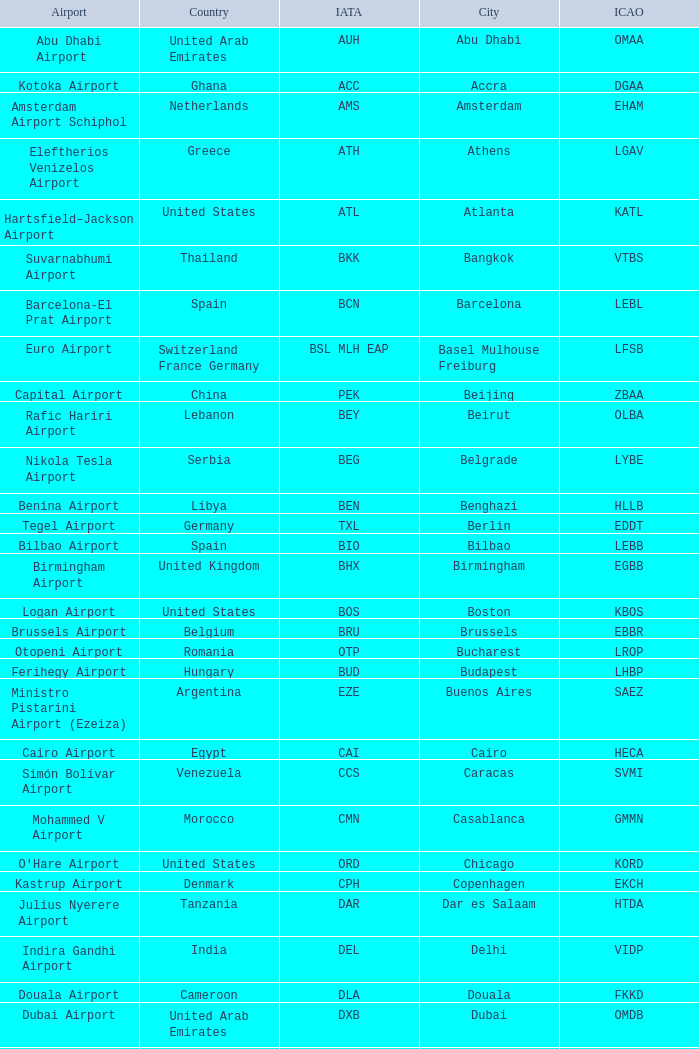Could you parse the entire table as a dict? {'header': ['Airport', 'Country', 'IATA', 'City', 'ICAO'], 'rows': [['Abu Dhabi Airport', 'United Arab Emirates', 'AUH', 'Abu Dhabi', 'OMAA'], ['Kotoka Airport', 'Ghana', 'ACC', 'Accra', 'DGAA'], ['Amsterdam Airport Schiphol', 'Netherlands', 'AMS', 'Amsterdam', 'EHAM'], ['Eleftherios Venizelos Airport', 'Greece', 'ATH', 'Athens', 'LGAV'], ['Hartsfield–Jackson Airport', 'United States', 'ATL', 'Atlanta', 'KATL'], ['Suvarnabhumi Airport', 'Thailand', 'BKK', 'Bangkok', 'VTBS'], ['Barcelona-El Prat Airport', 'Spain', 'BCN', 'Barcelona', 'LEBL'], ['Euro Airport', 'Switzerland France Germany', 'BSL MLH EAP', 'Basel Mulhouse Freiburg', 'LFSB'], ['Capital Airport', 'China', 'PEK', 'Beijing', 'ZBAA'], ['Rafic Hariri Airport', 'Lebanon', 'BEY', 'Beirut', 'OLBA'], ['Nikola Tesla Airport', 'Serbia', 'BEG', 'Belgrade', 'LYBE'], ['Benina Airport', 'Libya', 'BEN', 'Benghazi', 'HLLB'], ['Tegel Airport', 'Germany', 'TXL', 'Berlin', 'EDDT'], ['Bilbao Airport', 'Spain', 'BIO', 'Bilbao', 'LEBB'], ['Birmingham Airport', 'United Kingdom', 'BHX', 'Birmingham', 'EGBB'], ['Logan Airport', 'United States', 'BOS', 'Boston', 'KBOS'], ['Brussels Airport', 'Belgium', 'BRU', 'Brussels', 'EBBR'], ['Otopeni Airport', 'Romania', 'OTP', 'Bucharest', 'LROP'], ['Ferihegy Airport', 'Hungary', 'BUD', 'Budapest', 'LHBP'], ['Ministro Pistarini Airport (Ezeiza)', 'Argentina', 'EZE', 'Buenos Aires', 'SAEZ'], ['Cairo Airport', 'Egypt', 'CAI', 'Cairo', 'HECA'], ['Simón Bolívar Airport', 'Venezuela', 'CCS', 'Caracas', 'SVMI'], ['Mohammed V Airport', 'Morocco', 'CMN', 'Casablanca', 'GMMN'], ["O'Hare Airport", 'United States', 'ORD', 'Chicago', 'KORD'], ['Kastrup Airport', 'Denmark', 'CPH', 'Copenhagen', 'EKCH'], ['Julius Nyerere Airport', 'Tanzania', 'DAR', 'Dar es Salaam', 'HTDA'], ['Indira Gandhi Airport', 'India', 'DEL', 'Delhi', 'VIDP'], ['Douala Airport', 'Cameroon', 'DLA', 'Douala', 'FKKD'], ['Dubai Airport', 'United Arab Emirates', 'DXB', 'Dubai', 'OMDB'], ['Dublin Airport', 'Ireland', 'DUB', 'Dublin', 'EIDW'], ['Lohausen Airport', 'Germany', 'DUS', 'Düsseldorf', 'EDDL'], ['Peretola Airport', 'Italy', 'FLR', 'Florence', 'LIRQ'], ['Frankfurt am Main Airport', 'Germany', 'FRA', 'Frankfurt', 'EDDF'], ['Cointrin Airport', 'Switzerland', 'GVA', 'Geneva', 'LSGG'], ['Cristoforo Colombo Airport', 'Italy', 'GOA', 'Genoa', 'LIMJ'], ['Gothenburg-Landvetter Airport', 'Sweden', 'GOT', 'Gothenburg [begins 2013-12-14]', 'ESGG'], ['Fuhlsbüttel Airport', 'Germany', 'HAM', 'Hamburg', 'EDDH'], ['Langenhagen Airport', 'Germany', 'HAJ', 'Hannover', 'EDDV'], ['Vantaa Airport', 'Finland', 'HEL', 'Helsinki', 'EFHK'], ['Tan Son Nhat Airport', 'Vietnam', 'SGN', 'Ho Chi Minh City', 'VVTS'], ['Chek Lap Kok Airport', 'Hong Kong', 'HKG', 'Hong Kong', 'VHHH'], ['Atatürk Airport', 'Turkey', 'IST', 'Istanbul', 'LTBA'], ['Soekarno–Hatta Airport', 'Indonesia', 'CGK', 'Jakarta', 'WIII'], ['King Abdulaziz Airport', 'Saudi Arabia', 'JED', 'Jeddah', 'OEJN'], ['OR Tambo Airport', 'South Africa', 'JNB', 'Johannesburg', 'FAJS'], ['Jinnah Airport', 'Pakistan', 'KHI', 'Karachi', 'OPKC'], ['Boryspil International Airport', 'Ukraine', 'KBP', 'Kiev', 'UKBB'], ['Murtala Muhammed Airport', 'Nigeria', 'LOS', 'Lagos', 'DNMM'], ["Leon M'ba Airport", 'Gabon', 'LBV', 'Libreville', 'FOOL'], ['Portela Airport', 'Portugal', 'LIS', 'Lisbon', 'LPPT'], ['City Airport', 'United Kingdom', 'LCY', 'London', 'EGLC'], ['Gatwick Airport', 'United Kingdom', 'LGW', 'London [begins 2013-12-14]', 'EGKK'], ['Heathrow Airport', 'United Kingdom', 'LHR', 'London', 'EGLL'], ['Los Angeles International Airport', 'United States', 'LAX', 'Los Angeles', 'KLAX'], ['Agno Airport', 'Switzerland', 'LUG', 'Lugano', 'LSZA'], ['Findel Airport', 'Luxembourg', 'LUX', 'Luxembourg City', 'ELLX'], ['Saint-Exupéry Airport', 'France', 'LYS', 'Lyon', 'LFLL'], ['Madrid-Barajas Airport', 'Spain', 'MAD', 'Madrid', 'LEMD'], ['Saint Isabel Airport', 'Equatorial Guinea', 'SSG', 'Malabo', 'FGSL'], ['Málaga-Costa del Sol Airport', 'Spain', 'AGP', 'Malaga', 'LEMG'], ['Ringway Airport', 'United Kingdom', 'MAN', 'Manchester', 'EGCC'], ['Ninoy Aquino Airport', 'Philippines', 'MNL', 'Manila', 'RPLL'], ['Menara Airport', 'Morocco', 'RAK', 'Marrakech [begins 2013-11-01]', 'GMMX'], ['Miami Airport', 'United States', 'MIA', 'Miami', 'KMIA'], ['Malpensa Airport', 'Italy', 'MXP', 'Milan', 'LIMC'], ['Minneapolis Airport', 'United States', 'MSP', 'Minneapolis', 'KMSP'], ['Pierre Elliott Trudeau Airport', 'Canada', 'YUL', 'Montreal', 'CYUL'], ['Domodedovo Airport', 'Russia', 'DME', 'Moscow', 'UUDD'], ['Chhatrapati Shivaji Airport', 'India', 'BOM', 'Mumbai', 'VABB'], ['Franz Josef Strauss Airport', 'Germany', 'MUC', 'Munich', 'EDDM'], ['Seeb Airport', 'Oman', 'MCT', 'Muscat', 'OOMS'], ['Jomo Kenyatta Airport', 'Kenya', 'NBO', 'Nairobi', 'HKJK'], ['Liberty Airport', 'United States', 'EWR', 'Newark', 'KEWR'], ['John F Kennedy Airport', 'United States', 'JFK', 'New York City', 'KJFK'], ["Côte d'Azur Airport", 'France', 'NCE', 'Nice', 'LFMN'], ['Nuremberg Airport', 'Germany', 'NUE', 'Nuremberg', 'EDDN'], ['Gardermoen Airport', 'Norway', 'OSL', 'Oslo', 'ENGM'], ['Palma de Mallorca Airport', 'Spain', 'PMI', 'Palma de Mallorca', 'LFPA'], ['Charles de Gaulle Airport', 'France', 'CDG', 'Paris', 'LFPG'], ['Francisco de Sa Carneiro Airport', 'Portugal', 'OPO', 'Porto', 'LPPR'], ['Ruzyně Airport', 'Czech Republic', 'PRG', 'Prague', 'LKPR'], ['Riga Airport', 'Latvia', 'RIX', 'Riga', 'EVRA'], ['Galeão Airport', 'Brazil', 'GIG', 'Rio de Janeiro [resumes 2014-7-14]', 'SBGL'], ['King Khalid Airport', 'Saudi Arabia', 'RUH', 'Riyadh', 'OERK'], ['Leonardo da Vinci Airport', 'Italy', 'FCO', 'Rome', 'LIRF'], ['Pulkovo Airport', 'Russia', 'LED', 'Saint Petersburg', 'ULLI'], ['San Francisco Airport', 'United States', 'SFO', 'San Francisco', 'KSFO'], ['Comodoro Arturo Benitez Airport', 'Chile', 'SCL', 'Santiago', 'SCEL'], ['Guarulhos Airport', 'Brazil', 'GRU', 'São Paulo', 'SBGR'], ['Butmir Airport', 'Bosnia and Herzegovina', 'SJJ', 'Sarajevo', 'LQSA'], ['Sea-Tac Airport', 'United States', 'SEA', 'Seattle', 'KSEA'], ['Pudong Airport', 'China', 'PVG', 'Shanghai', 'ZSPD'], ['Changi Airport', 'Singapore', 'SIN', 'Singapore', 'WSSS'], ['Alexander the Great Airport', 'Republic of Macedonia', 'SKP', 'Skopje', 'LWSK'], ['Vrazhdebna Airport', 'Bulgaria', 'SOF', 'Sofia', 'LBSF'], ['Arlanda Airport', 'Sweden', 'ARN', 'Stockholm', 'ESSA'], ['Echterdingen Airport', 'Germany', 'STR', 'Stuttgart', 'EDDS'], ['Taoyuan Airport', 'Taiwan', 'TPE', 'Taipei', 'RCTP'], ['Imam Khomeini Airport', 'Iran', 'IKA', 'Tehran', 'OIIE'], ['Ben Gurion Airport', 'Israel', 'TLV', 'Tel Aviv', 'LLBG'], ['Macedonia Airport', 'Greece', 'SKG', 'Thessaloniki', 'LGTS'], ['Nënë Tereza Airport', 'Albania', 'TIA', 'Tirana', 'LATI'], ['Narita Airport', 'Japan', 'NRT', 'Tokyo', 'RJAA'], ['Pearson Airport', 'Canada', 'YYZ', 'Toronto', 'CYYZ'], ['Tripoli Airport', 'Libya', 'TIP', 'Tripoli', 'HLLT'], ['Carthage Airport', 'Tunisia', 'TUN', 'Tunis', 'DTTA'], ['Sandro Pertini Airport', 'Italy', 'TRN', 'Turin', 'LIMF'], ['Valencia Airport', 'Spain', 'VLC', 'Valencia', 'LEVC'], ['Marco Polo Airport', 'Italy', 'VCE', 'Venice', 'LIPZ'], ['Schwechat Airport', 'Austria', 'VIE', 'Vienna', 'LOWW'], ['Frederic Chopin Airport', 'Poland', 'WAW', 'Warsaw', 'EPWA'], ['Dulles Airport', 'United States', 'IAD', 'Washington DC', 'KIAD'], ['Yaounde Nsimalen Airport', 'Cameroon', 'NSI', 'Yaounde', 'FKYS'], ['Zvartnots Airport', 'Armenia', 'EVN', 'Yerevan', 'UDYZ'], ['Zurich Airport', 'Switzerland', 'ZRH', 'Zurich', 'LSZH']]} What is the ICAO of Douala city? FKKD. 